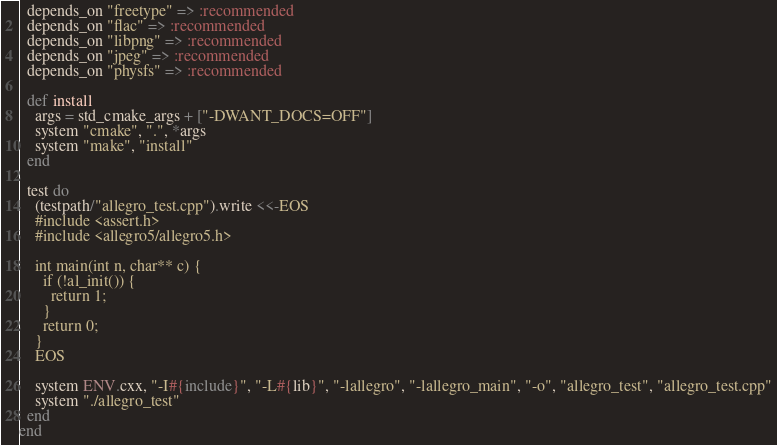Convert code to text. <code><loc_0><loc_0><loc_500><loc_500><_Ruby_>  depends_on "freetype" => :recommended
  depends_on "flac" => :recommended
  depends_on "libpng" => :recommended
  depends_on "jpeg" => :recommended
  depends_on "physfs" => :recommended

  def install
    args = std_cmake_args + ["-DWANT_DOCS=OFF"]
    system "cmake", ".", *args
    system "make", "install"
  end

  test do
    (testpath/"allegro_test.cpp").write <<-EOS
    #include <assert.h>
    #include <allegro5/allegro5.h>

    int main(int n, char** c) {
      if (!al_init()) {
        return 1;
      }
      return 0;
    }
    EOS

    system ENV.cxx, "-I#{include}", "-L#{lib}", "-lallegro", "-lallegro_main", "-o", "allegro_test", "allegro_test.cpp"
    system "./allegro_test"
  end
end
</code> 